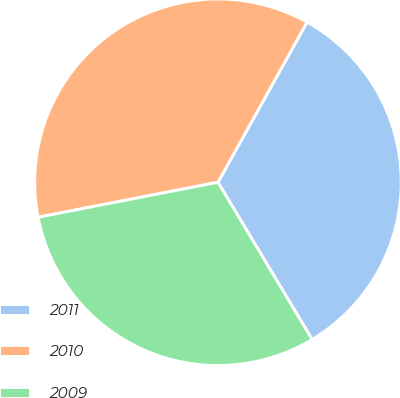Convert chart to OTSL. <chart><loc_0><loc_0><loc_500><loc_500><pie_chart><fcel>2011<fcel>2010<fcel>2009<nl><fcel>33.33%<fcel>36.14%<fcel>30.53%<nl></chart> 